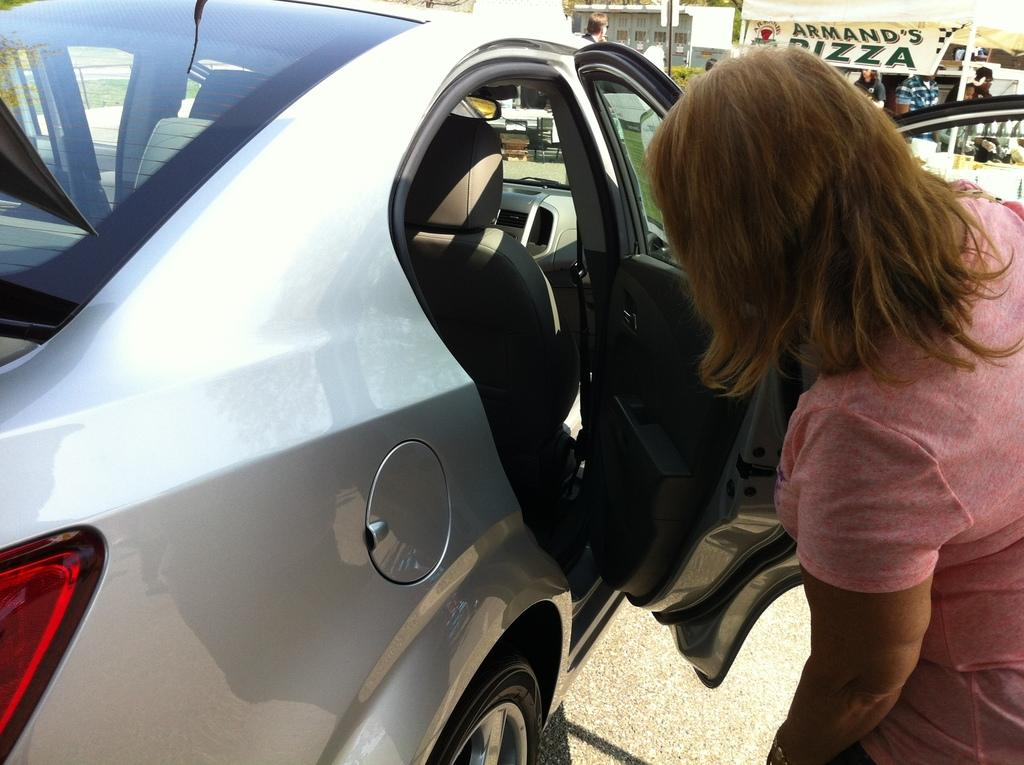Who is present in the image? There is a woman in the image. What is the woman wearing? The woman is wearing a pink shirt. Where is the woman located in the image? The woman is near the door of a car. What can be seen behind the car? There are people behind the car. What type of environment is visible in the background? There are plants and buildings visible in the background. How many credit cards does the woman have in her possession in the image? There is no information about credit cards or any financial items in the image. 